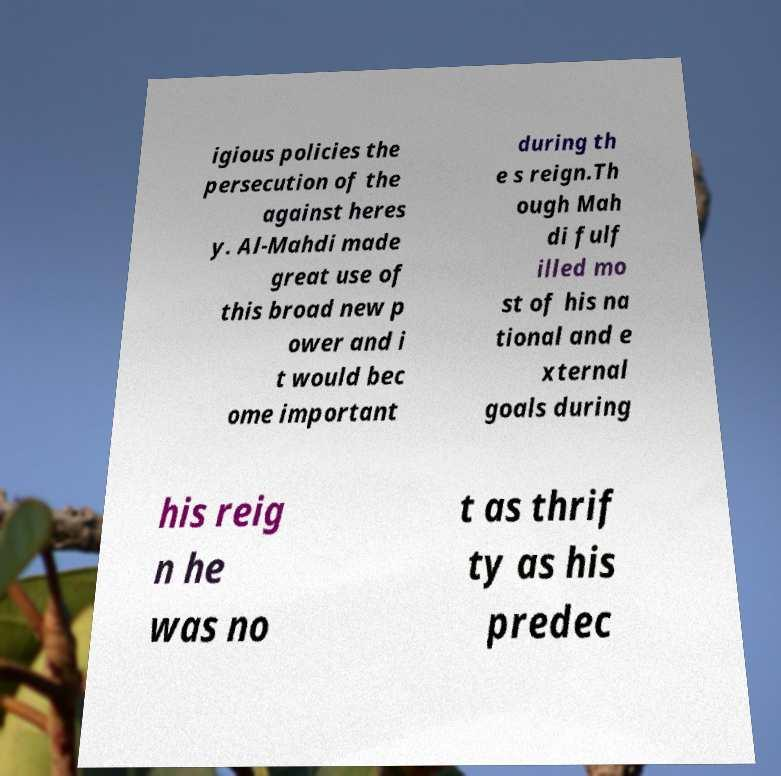Please read and relay the text visible in this image. What does it say? igious policies the persecution of the against heres y. Al-Mahdi made great use of this broad new p ower and i t would bec ome important during th e s reign.Th ough Mah di fulf illed mo st of his na tional and e xternal goals during his reig n he was no t as thrif ty as his predec 